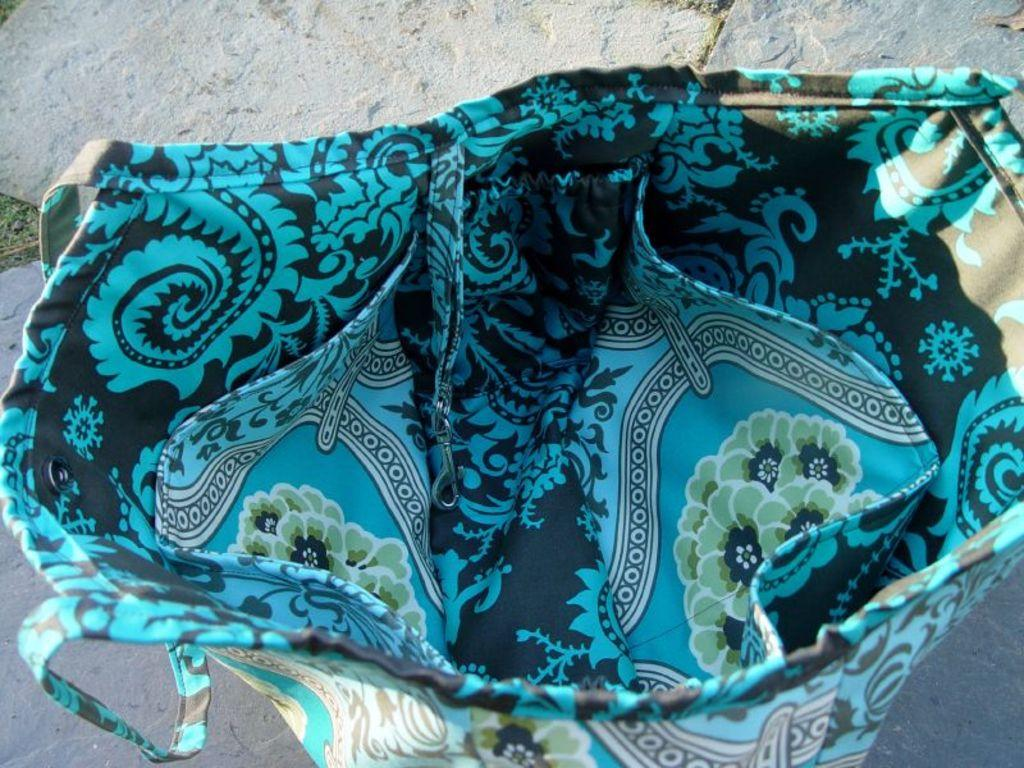What type of bag is in the image? There is a cloth handbag in the image. What colors can be seen on the handbag? The handbag is blue, black, green, and white in color. What feature allows the handbag to be carried? The handbag has handles. Where is the handbag located in the image? The handbag is placed on the floor. What type of learning is taking place in the image? There is no learning activity depicted in the image; it features a cloth handbag placed on the floor. Is there a swing present in the image? No, there is no swing present in the image. 